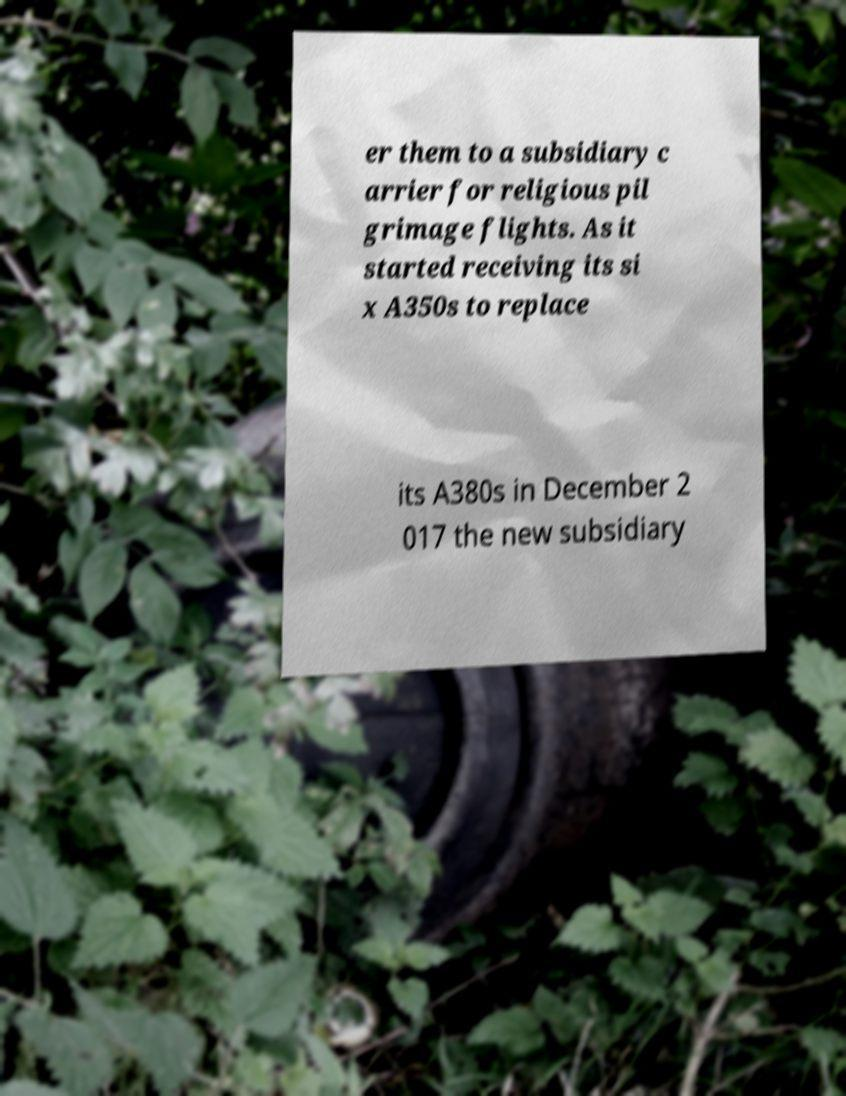Please identify and transcribe the text found in this image. er them to a subsidiary c arrier for religious pil grimage flights. As it started receiving its si x A350s to replace its A380s in December 2 017 the new subsidiary 